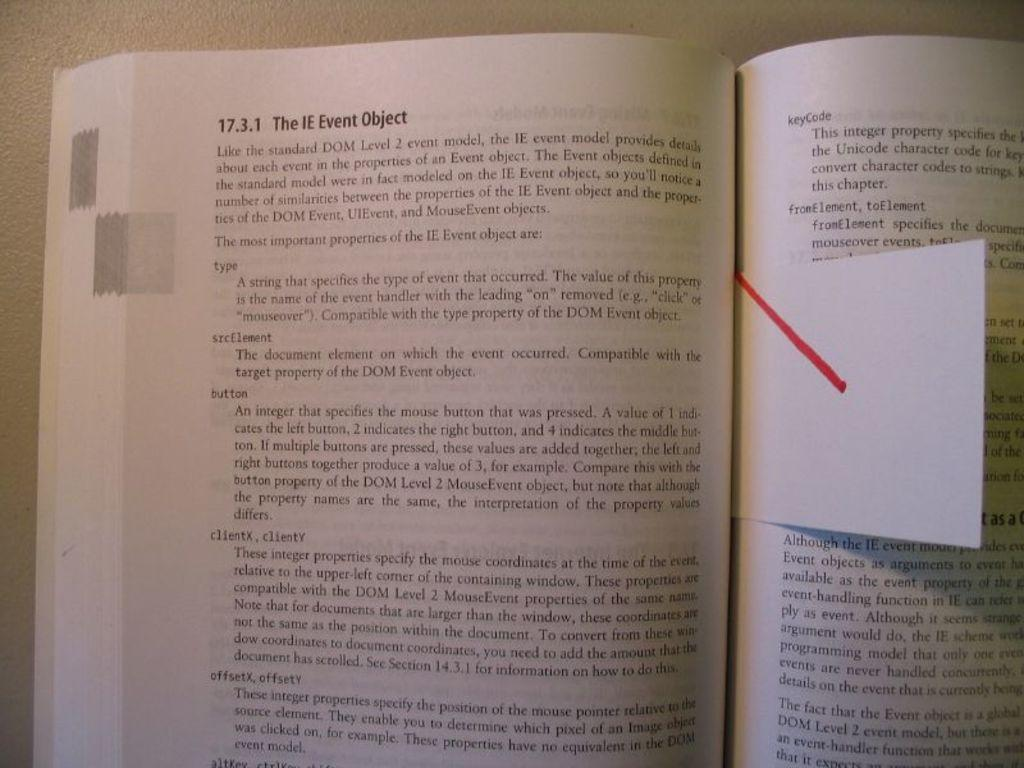<image>
Describe the image concisely. The book is open to chapter 17.3.1 The IE event object. 